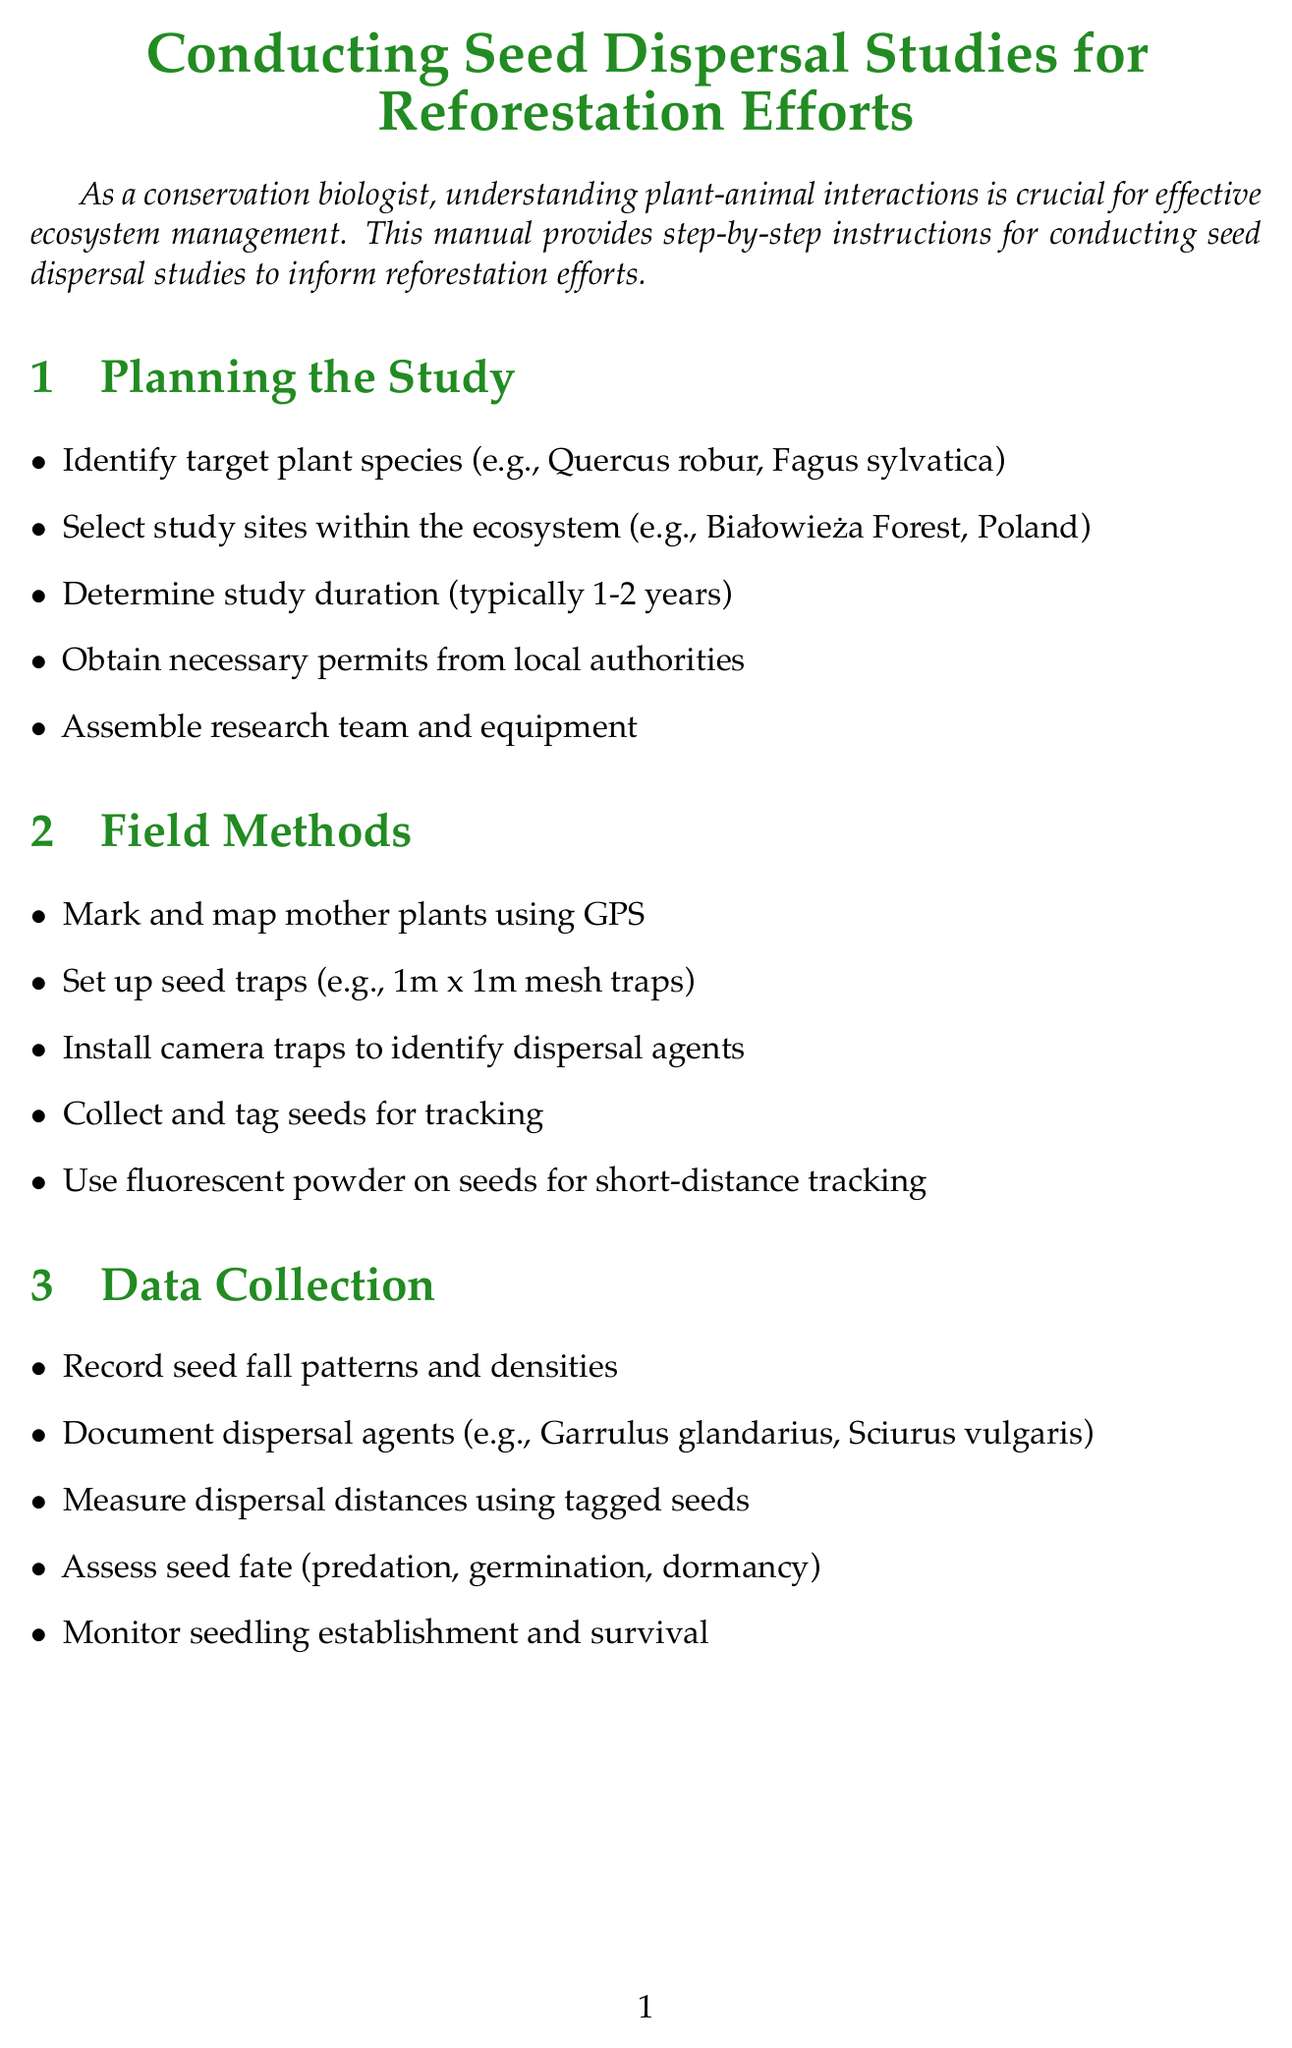What are the target plant species in the study? The document lists specific examples of target plant species, which are Quercus robur and Fagus sylvatica.
Answer: Quercus robur, Fagus sylvatica How long is the typical study duration? The typical duration for conducting seed dispersal studies is mentioned in the document as 1-2 years.
Answer: 1-2 years What type of traps are used in the field methods? The document specifies that 1m x 1m mesh traps are set up as seed traps.
Answer: 1m x 1m mesh traps What method is used to analyze seed viability? The document refers to the tetrazolium chloride test for analyzing seed viability in the laboratory analysis section.
Answer: tetrazolium chloride test What is one key dispersal agent mentioned for conservation? The document includes specific examples of dispersal agents such as Garrulus glandarius.
Answer: Garrulus glandarius What type of monitoring plots should be set up? According to the document, long-term monitoring plots should be established.
Answer: long-term monitoring plots What is one strategy to attract dispersers to degraded areas? The document suggests developing strategies aimed at attracting dispersers to these areas.
Answer: strategies to attract dispersers What must be assessed alongside seedling recruitment? The document mentions that changes in animal populations and behavior need to be assessed alongside seedling recruitment.
Answer: changes in animal populations and behavior 